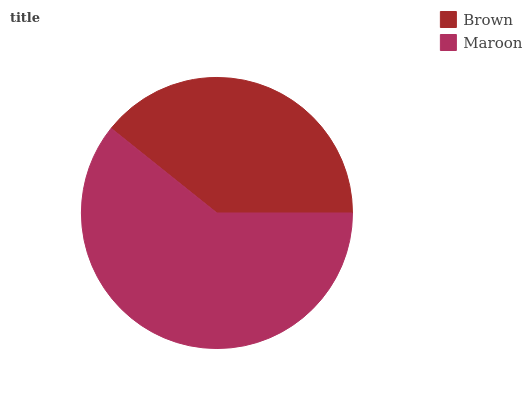Is Brown the minimum?
Answer yes or no. Yes. Is Maroon the maximum?
Answer yes or no. Yes. Is Maroon the minimum?
Answer yes or no. No. Is Maroon greater than Brown?
Answer yes or no. Yes. Is Brown less than Maroon?
Answer yes or no. Yes. Is Brown greater than Maroon?
Answer yes or no. No. Is Maroon less than Brown?
Answer yes or no. No. Is Maroon the high median?
Answer yes or no. Yes. Is Brown the low median?
Answer yes or no. Yes. Is Brown the high median?
Answer yes or no. No. Is Maroon the low median?
Answer yes or no. No. 